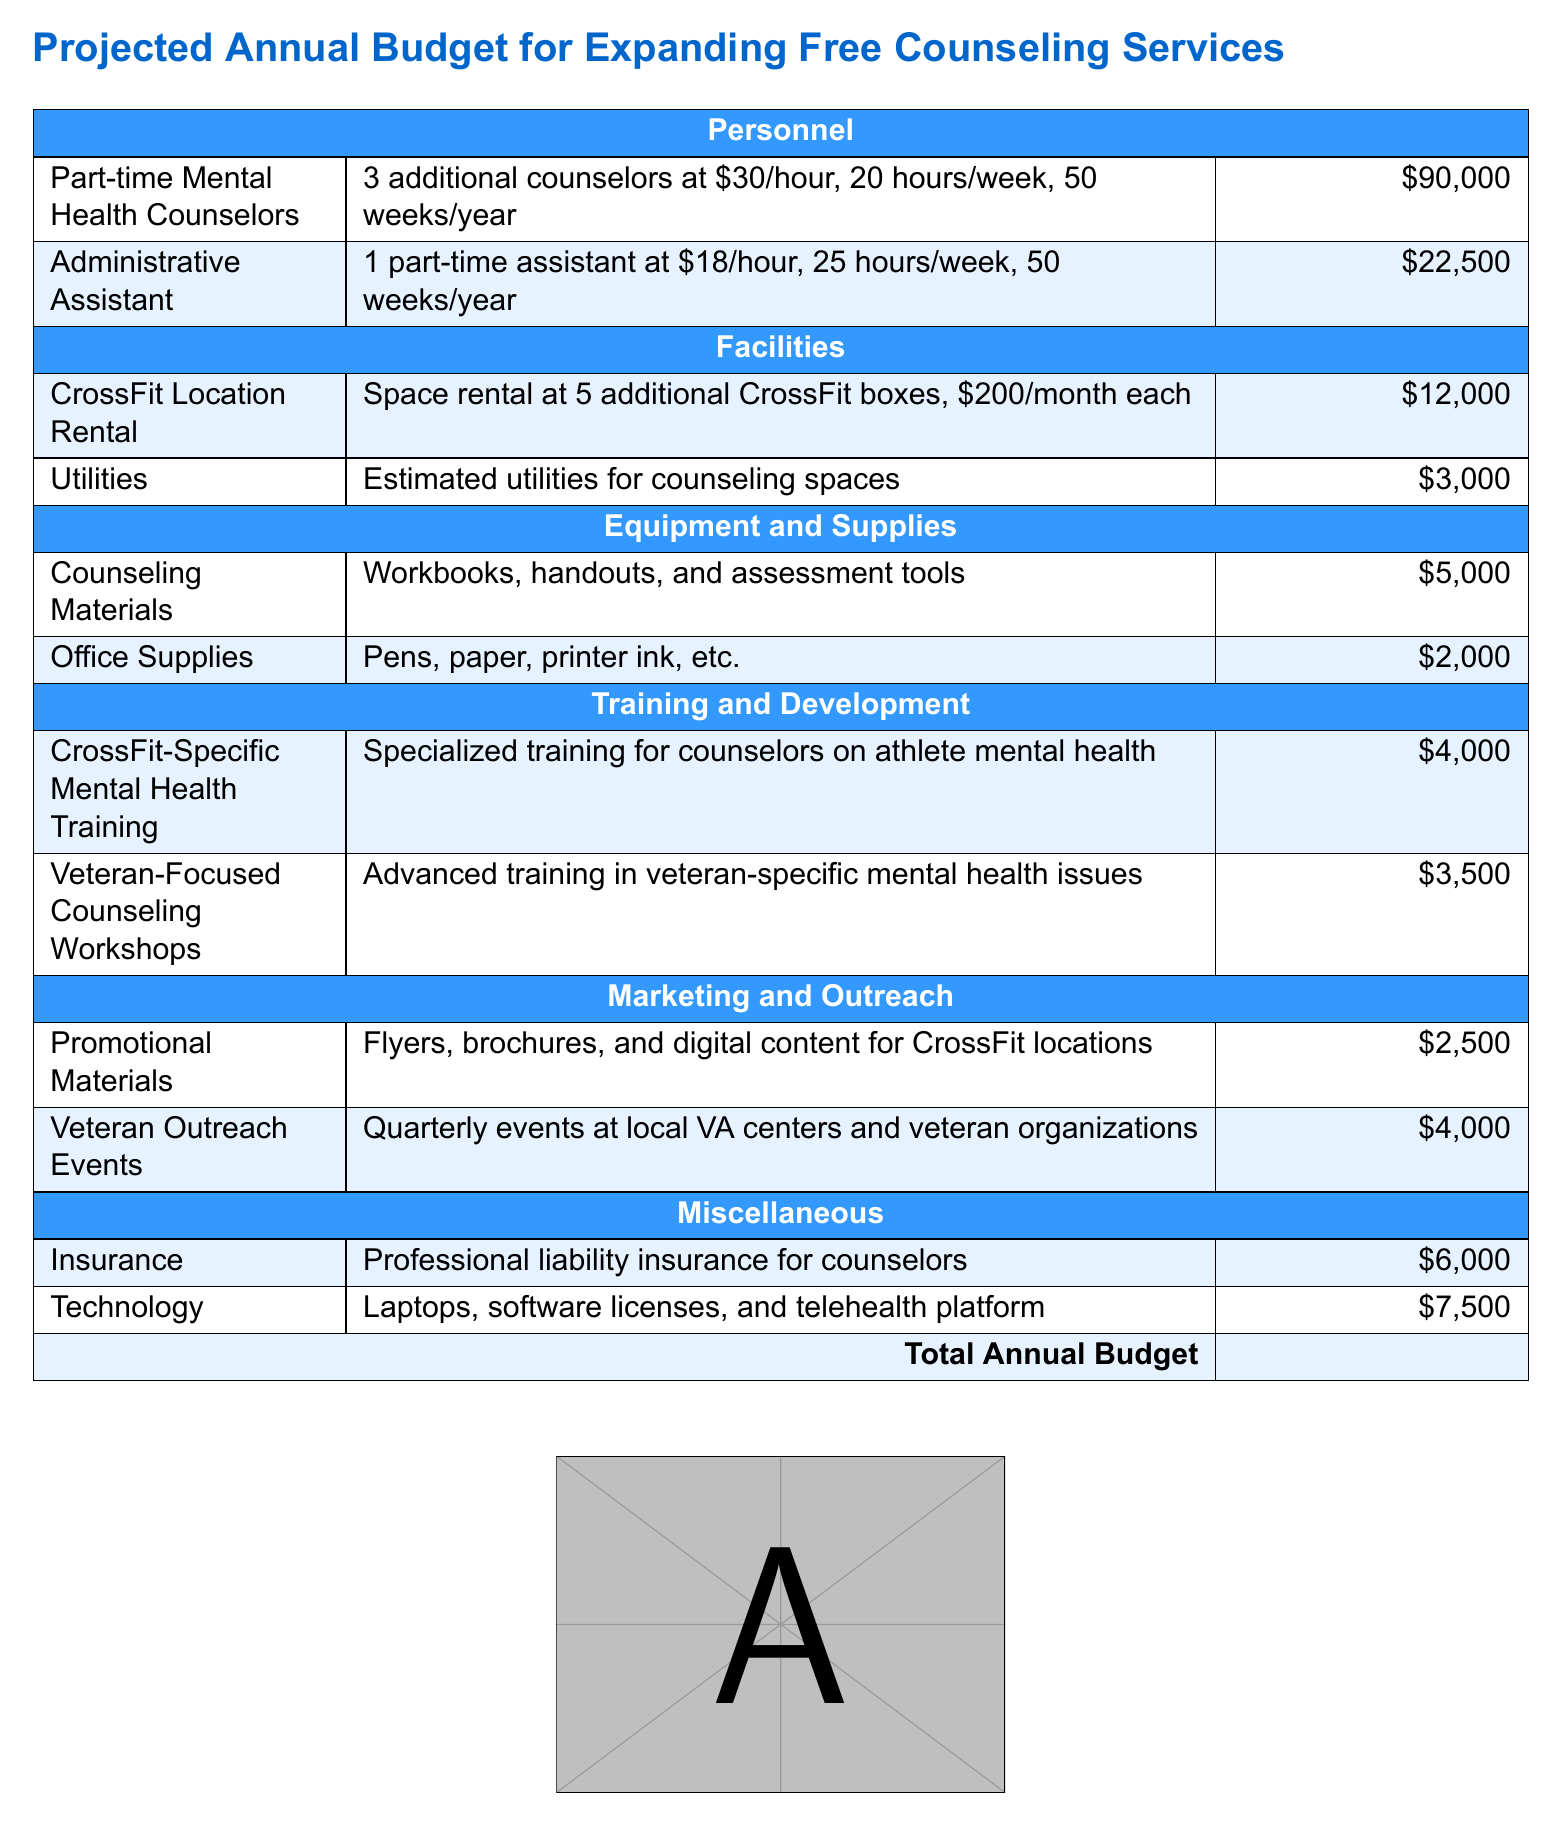What is the total annual budget? The total annual budget is the sum of all expenses listed in the document.
Answer: \$162,000 How many part-time mental health counselors are being hired? The document specifies the number of additional counselors to be hired.
Answer: 3 What is the cost of utilities for counseling spaces? The document lists the estimated cost for utilities under the Facilities section.
Answer: \$3,000 What type of training does the document mention for counselors? The document outlines specific training goals for counselors, indicating the type of training required.
Answer: CrossFit-Specific Mental Health Training How much is allocated for veteran outreach events? The document provides a specific budget for outreach activities targeting veterans.
Answer: \$4,000 What is the hourly rate for the administrative assistant? The document specifies the hourly wage for the administrative assistant in the Personnel section.
Answer: \$18/hour What are the total estimated costs for counseling materials? The total cost for materials used in counseling sessions is listed in the Equipment and Supplies section.
Answer: \$5,000 How many CrossFit locations are being accounted for in the rental costs? The document details how many locations are included in the space rental budget.
Answer: 5 What professional expense is assigned \$6,000? The document specifies a cost directly related to professional insurance under Miscellaneous.
Answer: Insurance 